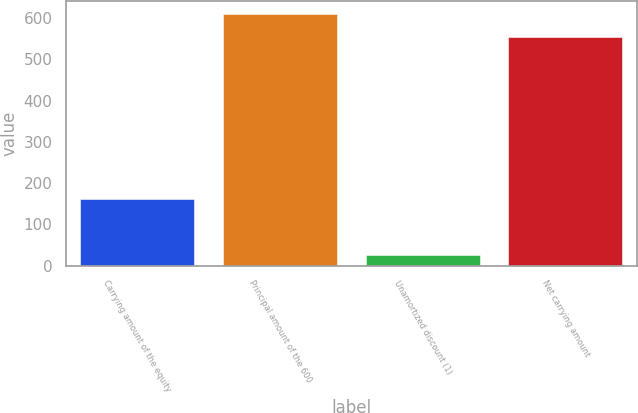<chart> <loc_0><loc_0><loc_500><loc_500><bar_chart><fcel>Carrying amount of the equity<fcel>Principal amount of the 600<fcel>Unamortized discount (1)<fcel>Net carrying amount<nl><fcel>162<fcel>610.5<fcel>25<fcel>555<nl></chart> 